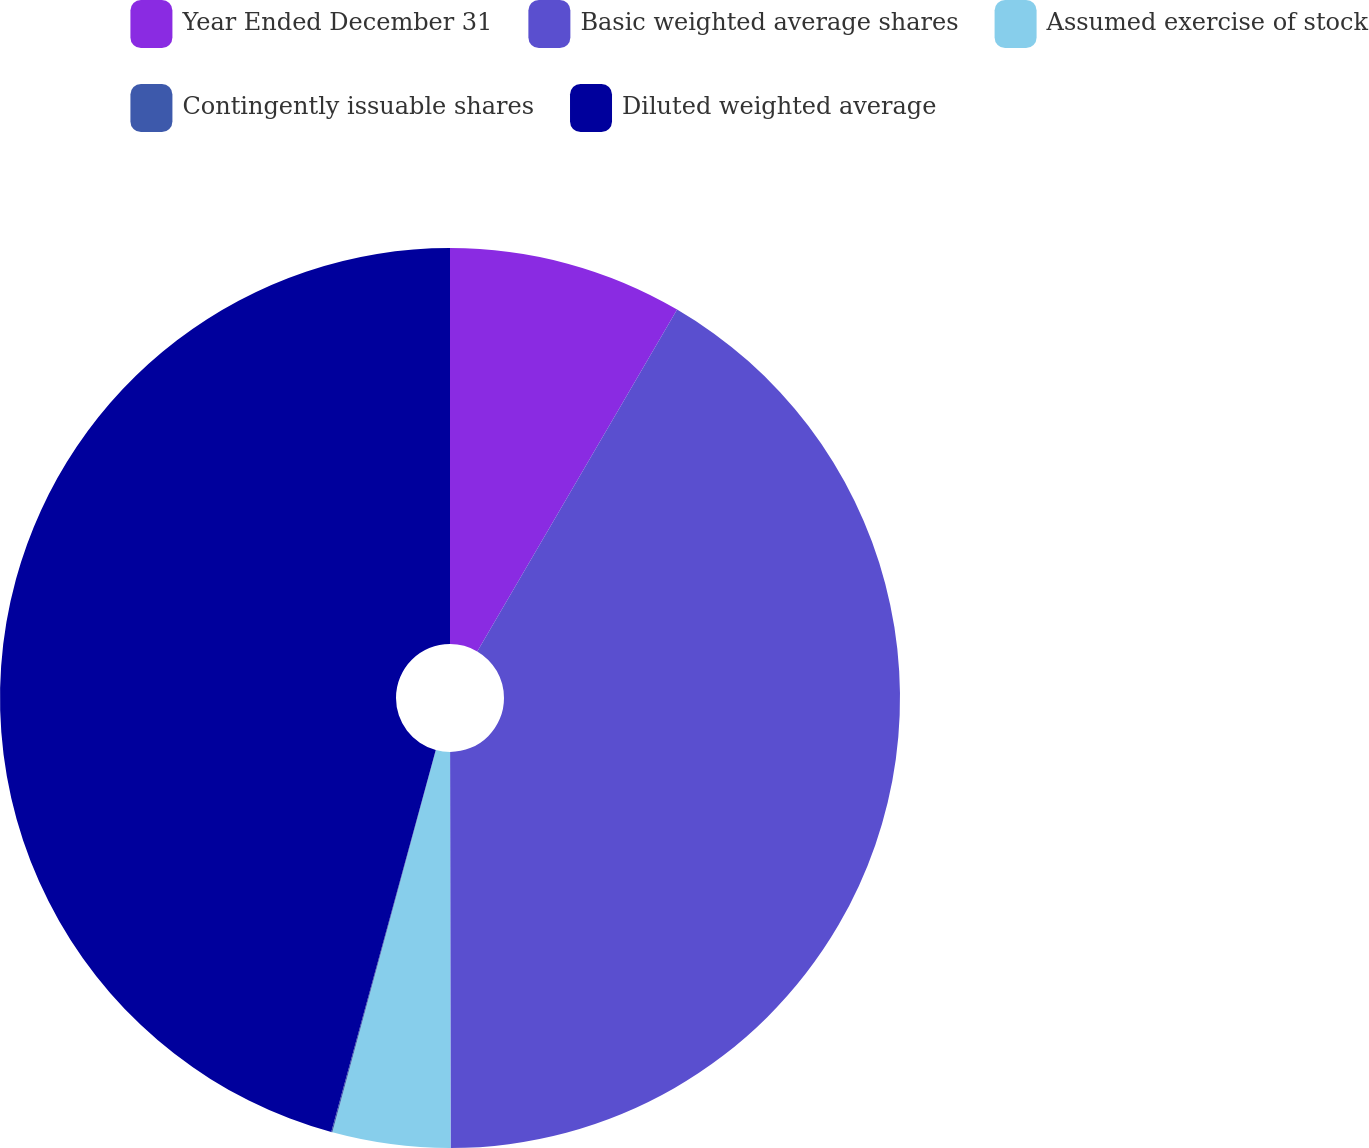Convert chart to OTSL. <chart><loc_0><loc_0><loc_500><loc_500><pie_chart><fcel>Year Ended December 31<fcel>Basic weighted average shares<fcel>Assumed exercise of stock<fcel>Contingently issuable shares<fcel>Diluted weighted average<nl><fcel>8.42%<fcel>41.56%<fcel>4.23%<fcel>0.04%<fcel>45.75%<nl></chart> 